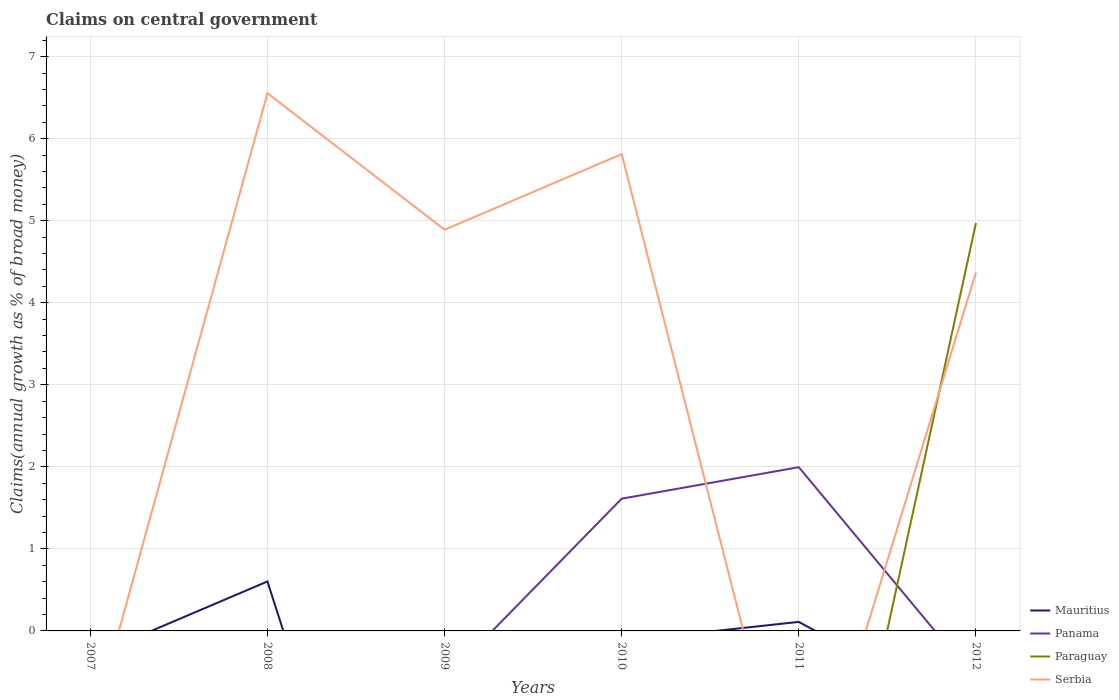How many different coloured lines are there?
Give a very brief answer. 4. Does the line corresponding to Mauritius intersect with the line corresponding to Panama?
Offer a terse response. Yes. Is the number of lines equal to the number of legend labels?
Ensure brevity in your answer.  No. What is the total percentage of broad money claimed on centeral government in Serbia in the graph?
Your answer should be very brief. 1.66. What is the difference between the highest and the second highest percentage of broad money claimed on centeral government in Paraguay?
Provide a succinct answer. 4.97. What is the difference between the highest and the lowest percentage of broad money claimed on centeral government in Serbia?
Offer a very short reply. 4. How many years are there in the graph?
Make the answer very short. 6. What is the difference between two consecutive major ticks on the Y-axis?
Your answer should be very brief. 1. Does the graph contain any zero values?
Give a very brief answer. Yes. Does the graph contain grids?
Offer a very short reply. Yes. How many legend labels are there?
Ensure brevity in your answer.  4. What is the title of the graph?
Your response must be concise. Claims on central government. What is the label or title of the X-axis?
Make the answer very short. Years. What is the label or title of the Y-axis?
Offer a very short reply. Claims(annual growth as % of broad money). What is the Claims(annual growth as % of broad money) in Mauritius in 2007?
Your answer should be compact. 0. What is the Claims(annual growth as % of broad money) in Paraguay in 2007?
Ensure brevity in your answer.  0. What is the Claims(annual growth as % of broad money) in Mauritius in 2008?
Your answer should be very brief. 0.6. What is the Claims(annual growth as % of broad money) of Serbia in 2008?
Keep it short and to the point. 6.55. What is the Claims(annual growth as % of broad money) in Mauritius in 2009?
Give a very brief answer. 0. What is the Claims(annual growth as % of broad money) in Panama in 2009?
Offer a very short reply. 0. What is the Claims(annual growth as % of broad money) of Serbia in 2009?
Your answer should be compact. 4.89. What is the Claims(annual growth as % of broad money) in Panama in 2010?
Give a very brief answer. 1.61. What is the Claims(annual growth as % of broad money) in Serbia in 2010?
Your response must be concise. 5.81. What is the Claims(annual growth as % of broad money) of Mauritius in 2011?
Your answer should be very brief. 0.11. What is the Claims(annual growth as % of broad money) of Panama in 2011?
Ensure brevity in your answer.  2. What is the Claims(annual growth as % of broad money) of Paraguay in 2011?
Provide a succinct answer. 0. What is the Claims(annual growth as % of broad money) of Serbia in 2011?
Ensure brevity in your answer.  0. What is the Claims(annual growth as % of broad money) in Mauritius in 2012?
Ensure brevity in your answer.  0. What is the Claims(annual growth as % of broad money) in Paraguay in 2012?
Provide a succinct answer. 4.97. What is the Claims(annual growth as % of broad money) of Serbia in 2012?
Make the answer very short. 4.37. Across all years, what is the maximum Claims(annual growth as % of broad money) in Mauritius?
Your response must be concise. 0.6. Across all years, what is the maximum Claims(annual growth as % of broad money) in Panama?
Provide a short and direct response. 2. Across all years, what is the maximum Claims(annual growth as % of broad money) in Paraguay?
Ensure brevity in your answer.  4.97. Across all years, what is the maximum Claims(annual growth as % of broad money) of Serbia?
Make the answer very short. 6.55. Across all years, what is the minimum Claims(annual growth as % of broad money) in Paraguay?
Offer a very short reply. 0. What is the total Claims(annual growth as % of broad money) of Mauritius in the graph?
Provide a short and direct response. 0.71. What is the total Claims(annual growth as % of broad money) of Panama in the graph?
Offer a very short reply. 3.61. What is the total Claims(annual growth as % of broad money) of Paraguay in the graph?
Your answer should be very brief. 4.97. What is the total Claims(annual growth as % of broad money) in Serbia in the graph?
Provide a short and direct response. 21.63. What is the difference between the Claims(annual growth as % of broad money) in Serbia in 2008 and that in 2009?
Keep it short and to the point. 1.66. What is the difference between the Claims(annual growth as % of broad money) of Serbia in 2008 and that in 2010?
Provide a succinct answer. 0.74. What is the difference between the Claims(annual growth as % of broad money) of Mauritius in 2008 and that in 2011?
Ensure brevity in your answer.  0.49. What is the difference between the Claims(annual growth as % of broad money) in Serbia in 2008 and that in 2012?
Your response must be concise. 2.18. What is the difference between the Claims(annual growth as % of broad money) of Serbia in 2009 and that in 2010?
Offer a terse response. -0.92. What is the difference between the Claims(annual growth as % of broad money) in Serbia in 2009 and that in 2012?
Offer a terse response. 0.52. What is the difference between the Claims(annual growth as % of broad money) of Panama in 2010 and that in 2011?
Provide a succinct answer. -0.38. What is the difference between the Claims(annual growth as % of broad money) of Serbia in 2010 and that in 2012?
Provide a short and direct response. 1.44. What is the difference between the Claims(annual growth as % of broad money) in Mauritius in 2008 and the Claims(annual growth as % of broad money) in Serbia in 2009?
Your response must be concise. -4.29. What is the difference between the Claims(annual growth as % of broad money) in Mauritius in 2008 and the Claims(annual growth as % of broad money) in Panama in 2010?
Your answer should be very brief. -1.01. What is the difference between the Claims(annual growth as % of broad money) in Mauritius in 2008 and the Claims(annual growth as % of broad money) in Serbia in 2010?
Your response must be concise. -5.21. What is the difference between the Claims(annual growth as % of broad money) in Mauritius in 2008 and the Claims(annual growth as % of broad money) in Panama in 2011?
Your answer should be compact. -1.39. What is the difference between the Claims(annual growth as % of broad money) in Mauritius in 2008 and the Claims(annual growth as % of broad money) in Paraguay in 2012?
Offer a very short reply. -4.37. What is the difference between the Claims(annual growth as % of broad money) of Mauritius in 2008 and the Claims(annual growth as % of broad money) of Serbia in 2012?
Make the answer very short. -3.77. What is the difference between the Claims(annual growth as % of broad money) in Panama in 2010 and the Claims(annual growth as % of broad money) in Paraguay in 2012?
Make the answer very short. -3.36. What is the difference between the Claims(annual growth as % of broad money) in Panama in 2010 and the Claims(annual growth as % of broad money) in Serbia in 2012?
Ensure brevity in your answer.  -2.76. What is the difference between the Claims(annual growth as % of broad money) in Mauritius in 2011 and the Claims(annual growth as % of broad money) in Paraguay in 2012?
Your answer should be very brief. -4.86. What is the difference between the Claims(annual growth as % of broad money) of Mauritius in 2011 and the Claims(annual growth as % of broad money) of Serbia in 2012?
Give a very brief answer. -4.26. What is the difference between the Claims(annual growth as % of broad money) in Panama in 2011 and the Claims(annual growth as % of broad money) in Paraguay in 2012?
Ensure brevity in your answer.  -2.98. What is the difference between the Claims(annual growth as % of broad money) in Panama in 2011 and the Claims(annual growth as % of broad money) in Serbia in 2012?
Make the answer very short. -2.37. What is the average Claims(annual growth as % of broad money) of Mauritius per year?
Your answer should be compact. 0.12. What is the average Claims(annual growth as % of broad money) in Panama per year?
Your answer should be very brief. 0.6. What is the average Claims(annual growth as % of broad money) of Paraguay per year?
Your response must be concise. 0.83. What is the average Claims(annual growth as % of broad money) of Serbia per year?
Your response must be concise. 3.6. In the year 2008, what is the difference between the Claims(annual growth as % of broad money) of Mauritius and Claims(annual growth as % of broad money) of Serbia?
Give a very brief answer. -5.95. In the year 2010, what is the difference between the Claims(annual growth as % of broad money) in Panama and Claims(annual growth as % of broad money) in Serbia?
Offer a very short reply. -4.2. In the year 2011, what is the difference between the Claims(annual growth as % of broad money) of Mauritius and Claims(annual growth as % of broad money) of Panama?
Keep it short and to the point. -1.89. In the year 2012, what is the difference between the Claims(annual growth as % of broad money) in Paraguay and Claims(annual growth as % of broad money) in Serbia?
Your response must be concise. 0.6. What is the ratio of the Claims(annual growth as % of broad money) in Serbia in 2008 to that in 2009?
Provide a succinct answer. 1.34. What is the ratio of the Claims(annual growth as % of broad money) of Serbia in 2008 to that in 2010?
Keep it short and to the point. 1.13. What is the ratio of the Claims(annual growth as % of broad money) of Mauritius in 2008 to that in 2011?
Offer a terse response. 5.48. What is the ratio of the Claims(annual growth as % of broad money) of Serbia in 2009 to that in 2010?
Your answer should be very brief. 0.84. What is the ratio of the Claims(annual growth as % of broad money) of Serbia in 2009 to that in 2012?
Ensure brevity in your answer.  1.12. What is the ratio of the Claims(annual growth as % of broad money) in Panama in 2010 to that in 2011?
Keep it short and to the point. 0.81. What is the ratio of the Claims(annual growth as % of broad money) in Serbia in 2010 to that in 2012?
Your response must be concise. 1.33. What is the difference between the highest and the second highest Claims(annual growth as % of broad money) in Serbia?
Your answer should be very brief. 0.74. What is the difference between the highest and the lowest Claims(annual growth as % of broad money) of Mauritius?
Provide a succinct answer. 0.6. What is the difference between the highest and the lowest Claims(annual growth as % of broad money) of Panama?
Your answer should be compact. 2. What is the difference between the highest and the lowest Claims(annual growth as % of broad money) of Paraguay?
Your answer should be very brief. 4.97. What is the difference between the highest and the lowest Claims(annual growth as % of broad money) of Serbia?
Your response must be concise. 6.55. 